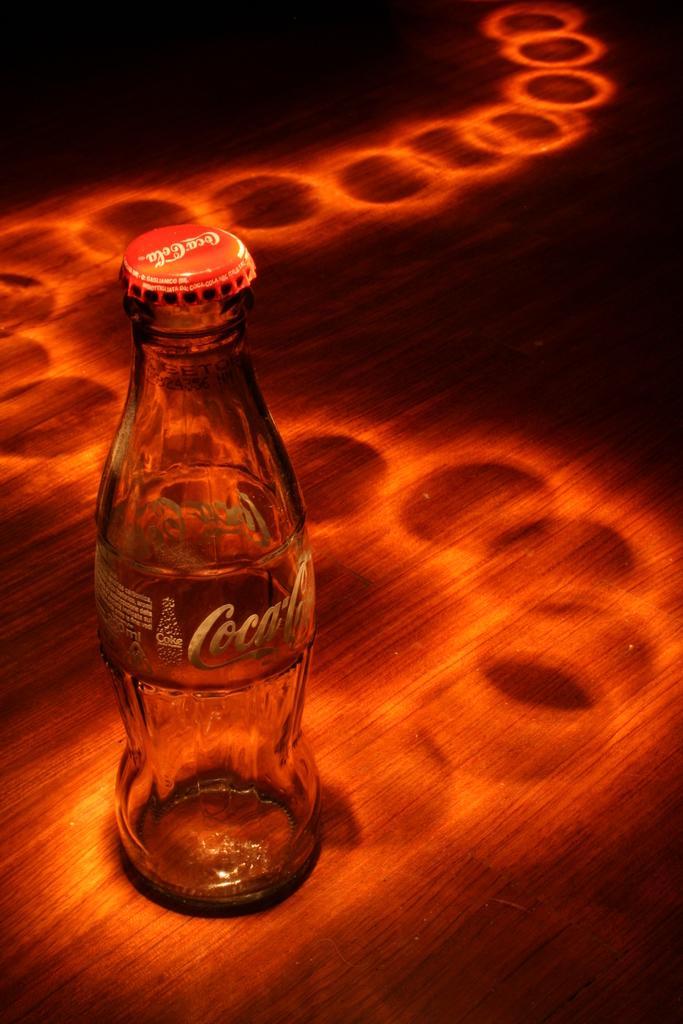How would you summarize this image in a sentence or two? In the center of the image there is a coke bottle on the bottle. 